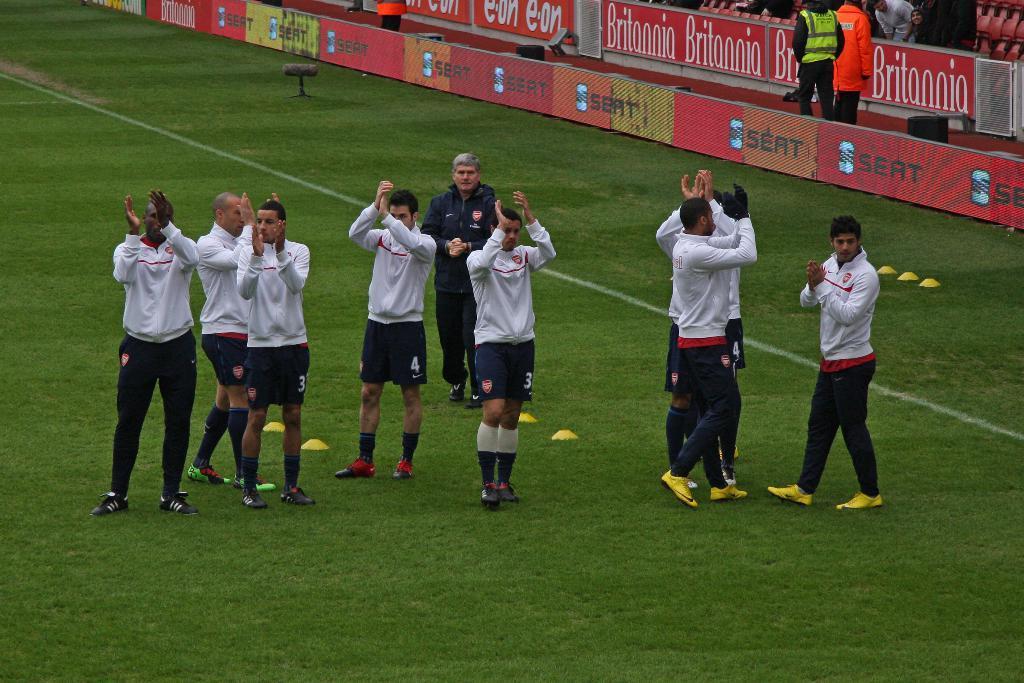Please provide a concise description of this image. In this picture, we see nine men are standing and all of them are clapping their hands. At the bottom of the picture, we see grass. Behind them, we see red color boards with some text written on it. We see two men in green jacket and orange jacket are standing. This picture might be clicked in the football field. 